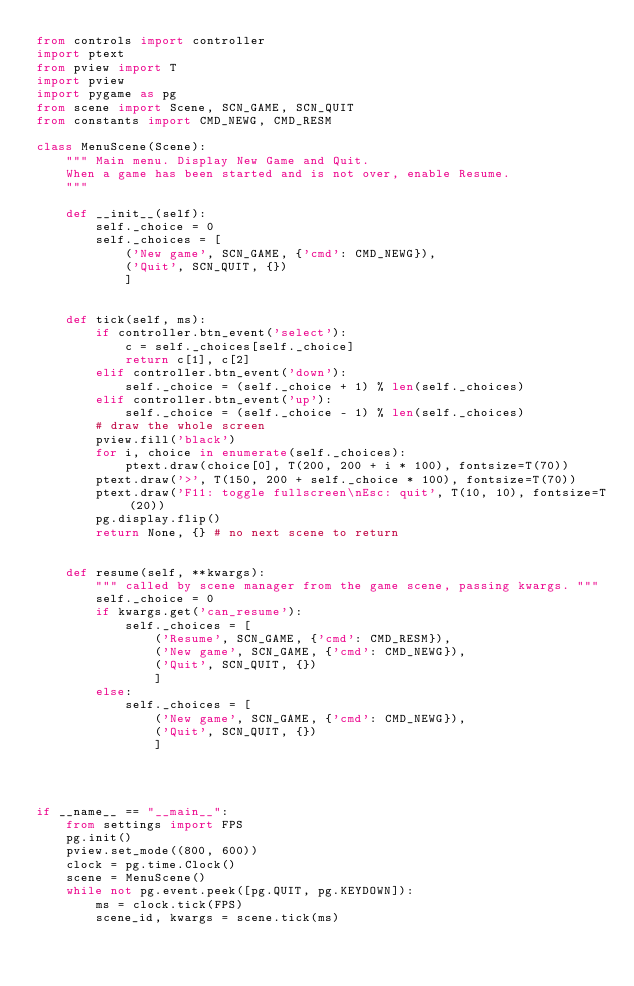Convert code to text. <code><loc_0><loc_0><loc_500><loc_500><_Python_>from controls import controller
import ptext
from pview import T
import pview
import pygame as pg
from scene import Scene, SCN_GAME, SCN_QUIT
from constants import CMD_NEWG, CMD_RESM

class MenuScene(Scene):
    """ Main menu. Display New Game and Quit.
    When a game has been started and is not over, enable Resume.
    """
    
    def __init__(self):
        self._choice = 0
        self._choices = [ 
            ('New game', SCN_GAME, {'cmd': CMD_NEWG}),
            ('Quit', SCN_QUIT, {})
            ]
        
        
    def tick(self, ms):
        if controller.btn_event('select'):
            c = self._choices[self._choice]
            return c[1], c[2] 
        elif controller.btn_event('down'):
            self._choice = (self._choice + 1) % len(self._choices)
        elif controller.btn_event('up'):
            self._choice = (self._choice - 1) % len(self._choices)
        # draw the whole screen
        pview.fill('black')
        for i, choice in enumerate(self._choices):
            ptext.draw(choice[0], T(200, 200 + i * 100), fontsize=T(70))
        ptext.draw('>', T(150, 200 + self._choice * 100), fontsize=T(70))
        ptext.draw('F11: toggle fullscreen\nEsc: quit', T(10, 10), fontsize=T(20))
        pg.display.flip()
        return None, {} # no next scene to return


    def resume(self, **kwargs):
        """ called by scene manager from the game scene, passing kwargs. """
        self._choice = 0
        if kwargs.get('can_resume'):
            self._choices = [
                ('Resume', SCN_GAME, {'cmd': CMD_RESM}), 
                ('New game', SCN_GAME, {'cmd': CMD_NEWG}),
                ('Quit', SCN_QUIT, {})
                ]            
        else:
            self._choices = [ 
                ('New game', SCN_GAME, {'cmd': CMD_NEWG}),
                ('Quit', SCN_QUIT, {})
                ]
            
            
        

if __name__ == "__main__":
    from settings import FPS
    pg.init()
    pview.set_mode((800, 600))
    clock = pg.time.Clock()
    scene = MenuScene()
    while not pg.event.peek([pg.QUIT, pg.KEYDOWN]):
        ms = clock.tick(FPS)        
        scene_id, kwargs = scene.tick(ms)
        
</code> 